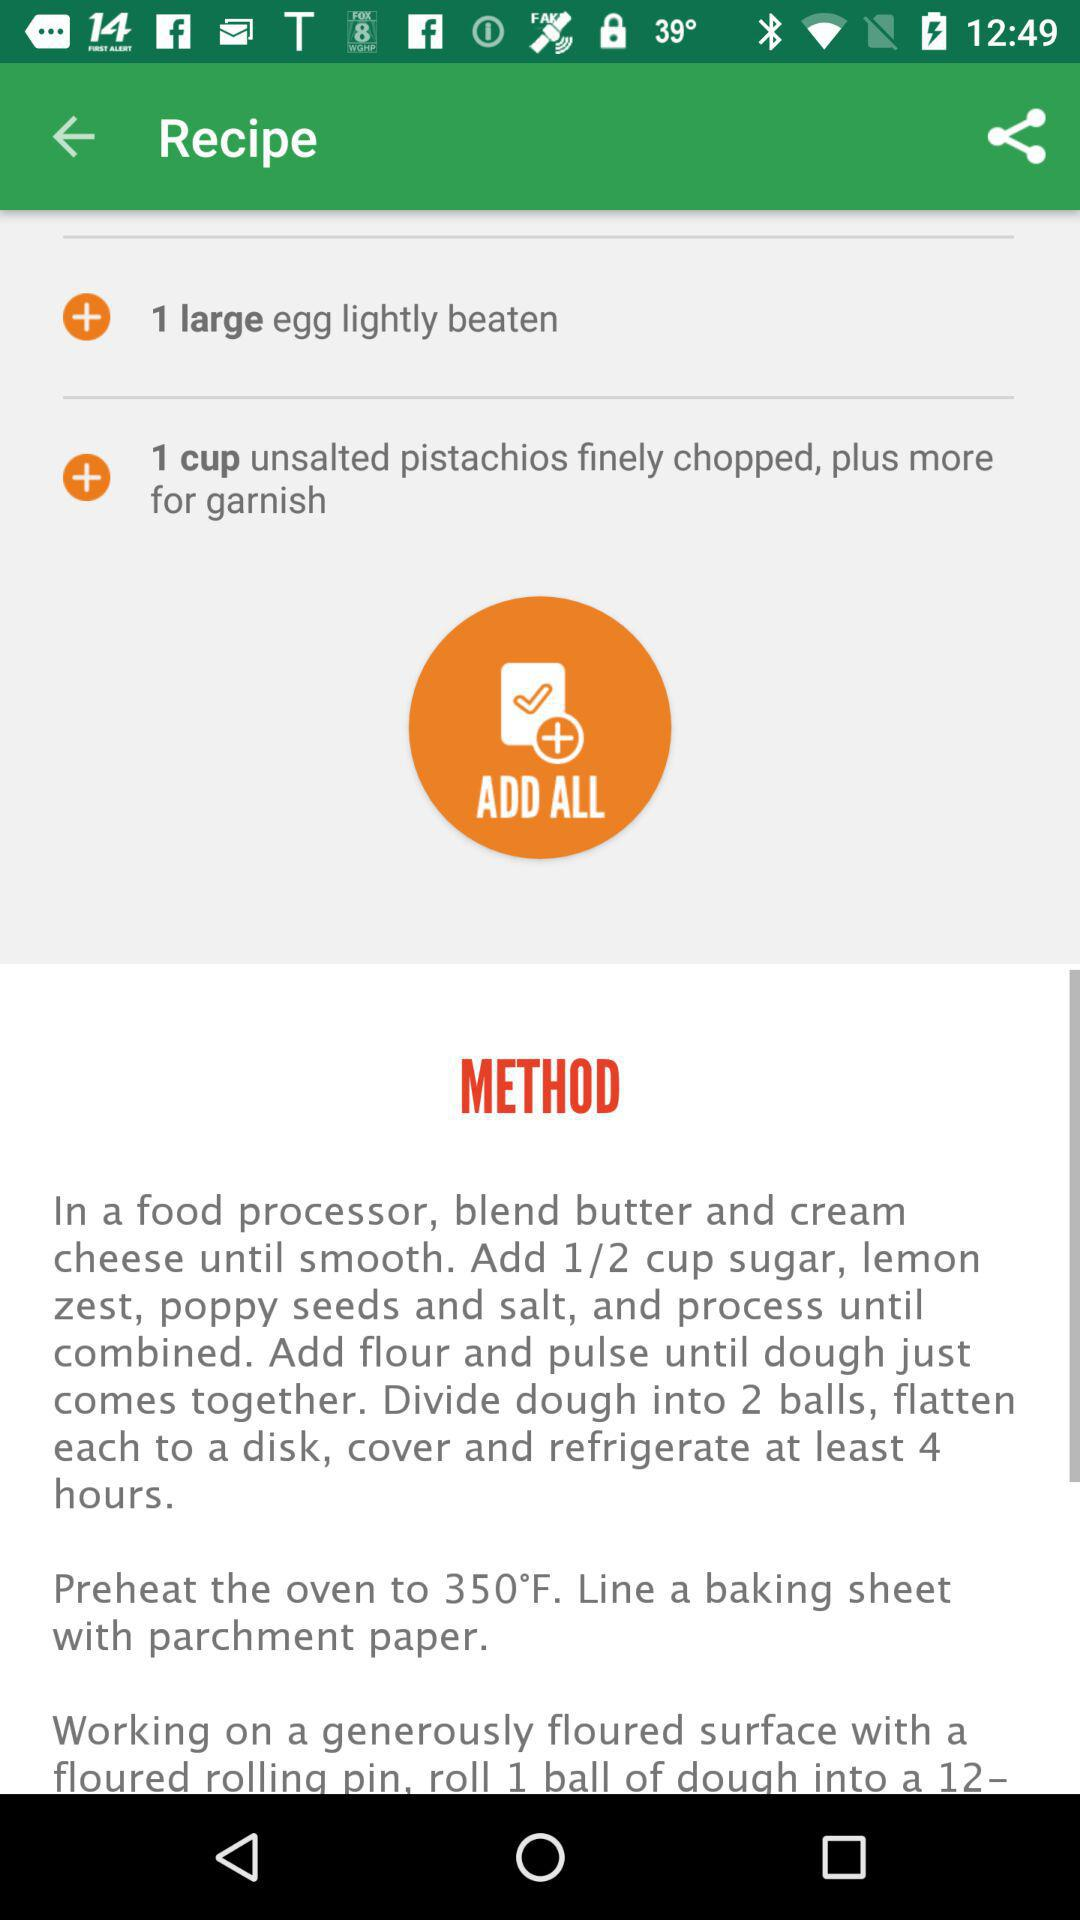At what temperature should the oven be set? The oven should be set at 350°F. 